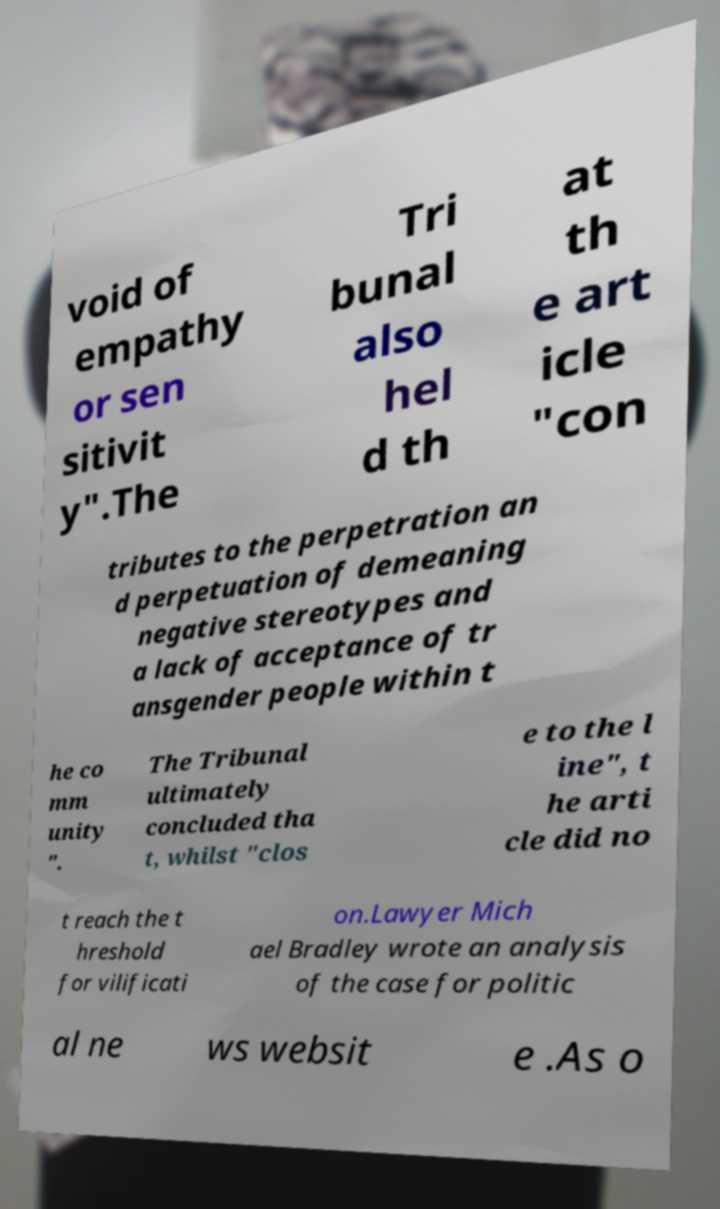There's text embedded in this image that I need extracted. Can you transcribe it verbatim? void of empathy or sen sitivit y".The Tri bunal also hel d th at th e art icle "con tributes to the perpetration an d perpetuation of demeaning negative stereotypes and a lack of acceptance of tr ansgender people within t he co mm unity ". The Tribunal ultimately concluded tha t, whilst "clos e to the l ine", t he arti cle did no t reach the t hreshold for vilificati on.Lawyer Mich ael Bradley wrote an analysis of the case for politic al ne ws websit e .As o 